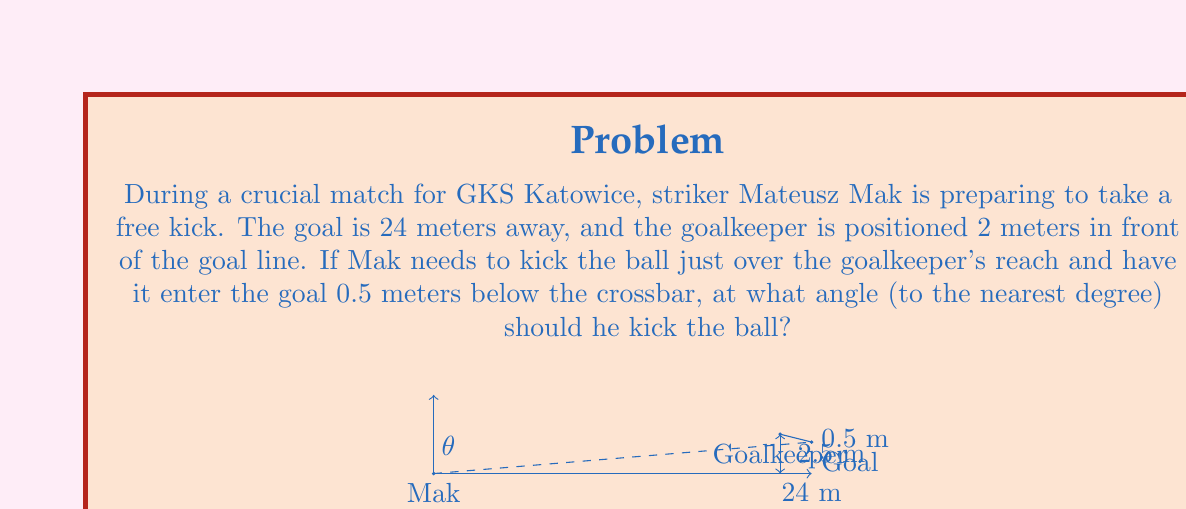Can you solve this math problem? To solve this problem, we'll use trigonometry. Let's break it down step by step:

1) First, we need to find the total height difference between Mak's kick point and the entry point of the ball into the goal:
   Height = Goalkeeper's position + Space above goalkeeper
   Height = 2.5 m + 0.5 m = 3 m

2) Now we have a right triangle with:
   - Adjacent side (horizontal distance) = 24 m
   - Opposite side (vertical distance) = 3 m

3) We can use the tangent function to find the angle:

   $$\tan(\theta) = \frac{\text{opposite}}{\text{adjacent}} = \frac{3}{24} = \frac{1}{8} = 0.125$$

4) To find the angle, we need to use the inverse tangent (arctan or $\tan^{-1}$):

   $$\theta = \tan^{-1}(0.125)$$

5) Using a calculator or trigonometric tables:

   $$\theta \approx 7.125^\circ$$

6) Rounding to the nearest degree:

   $$\theta \approx 7^\circ$$

Therefore, Mateusz Mak should kick the ball at an angle of approximately 7 degrees to clear the goalkeeper and enter the goal as described.
Answer: 7° 